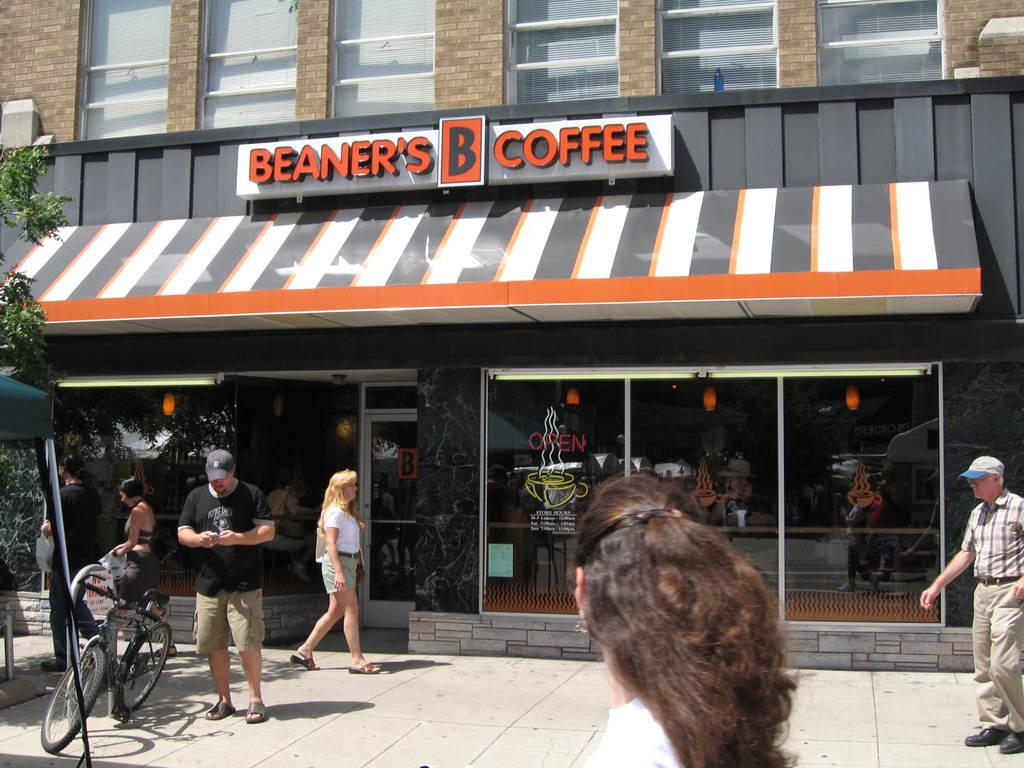<image>
Provide a brief description of the given image. People walking in front of a shop named Beaner's B Coffee. 